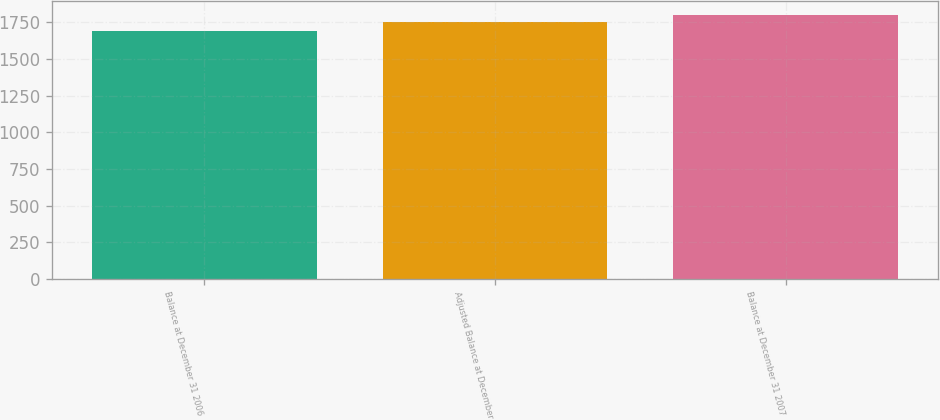Convert chart to OTSL. <chart><loc_0><loc_0><loc_500><loc_500><bar_chart><fcel>Balance at December 31 2006<fcel>Adjusted Balance at December<fcel>Balance at December 31 2007<nl><fcel>1689<fcel>1752<fcel>1804<nl></chart> 